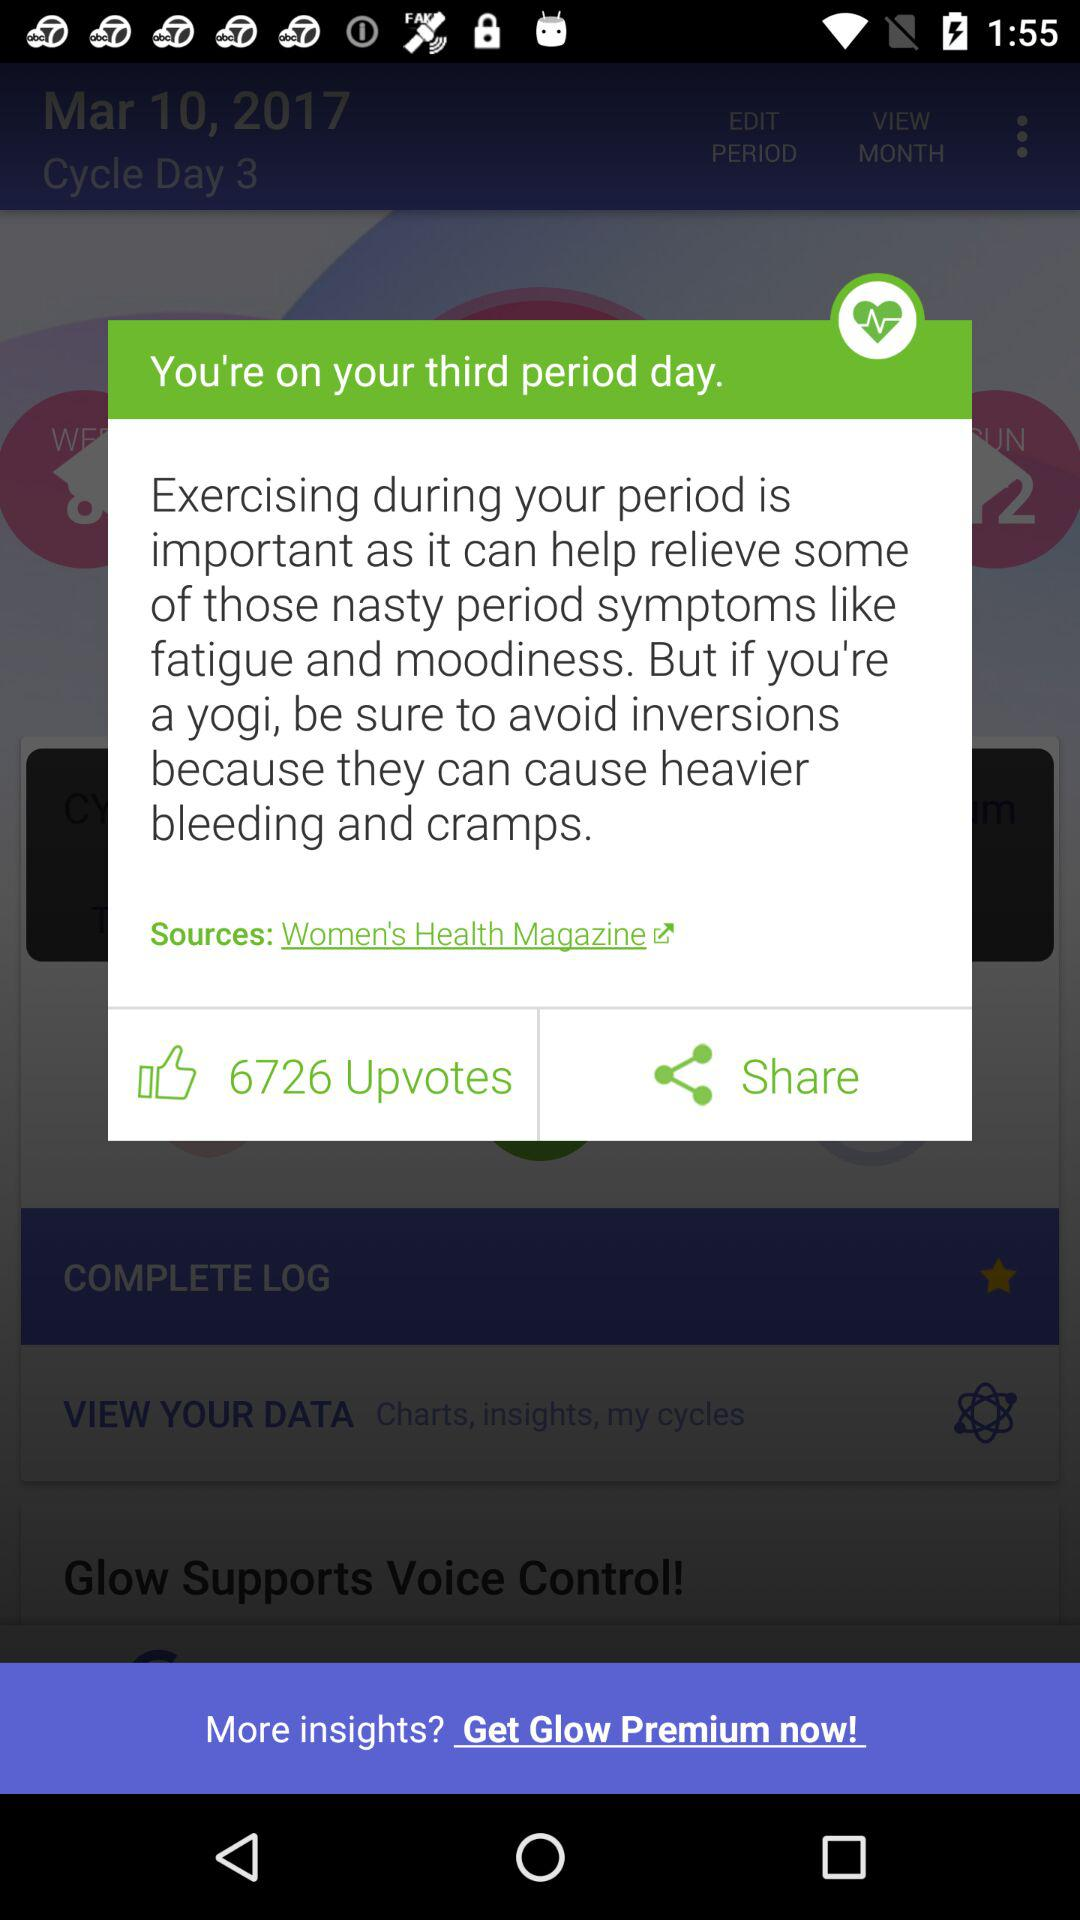What are the sources? The source is "Women's Health" magazine. 